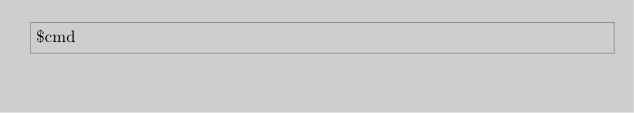Convert code to text. <code><loc_0><loc_0><loc_500><loc_500><_Bash_>$cmd
</code> 